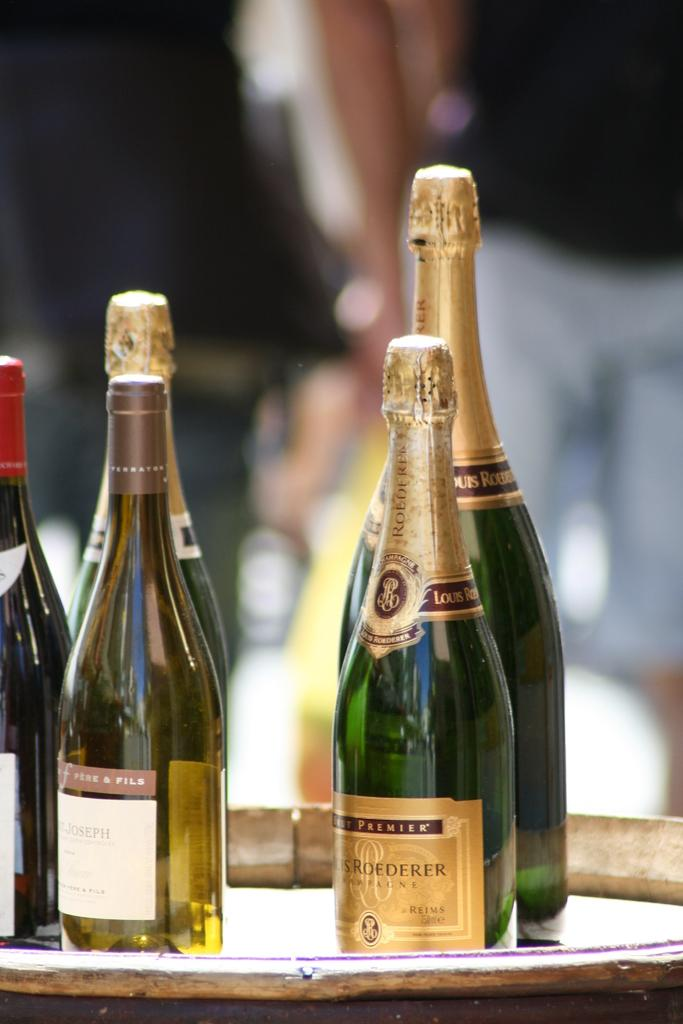What is the main subject of the image? The main subject of the image is a bunch of wine bottles. Where are the wine bottles located in the image? The wine bottles are on a table in the image. What type of plate is being used to serve the zephyr in the image? There is no mention of zephyr or a plate in the image; it only features a bunch of wine bottles on a table. 